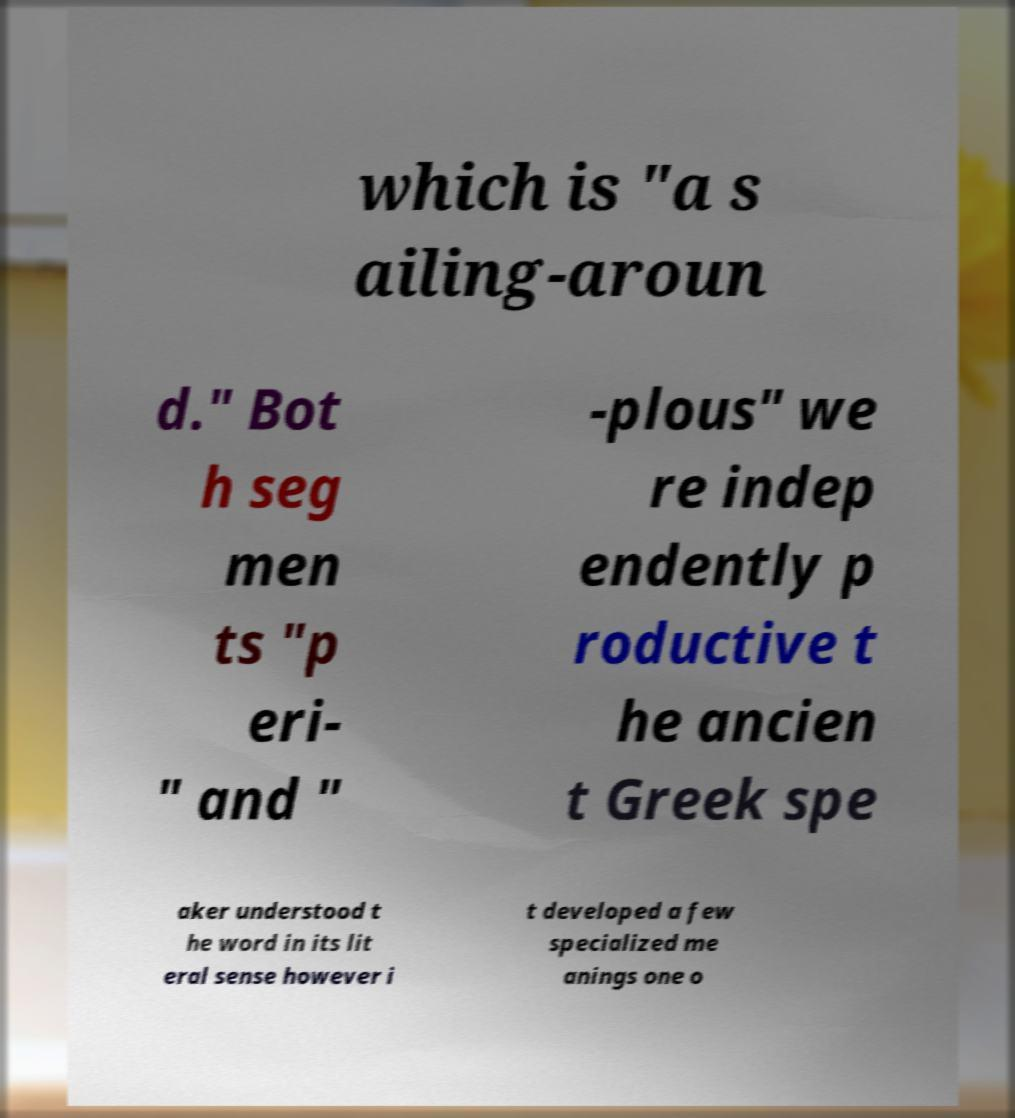Please identify and transcribe the text found in this image. which is "a s ailing-aroun d." Bot h seg men ts "p eri- " and " -plous" we re indep endently p roductive t he ancien t Greek spe aker understood t he word in its lit eral sense however i t developed a few specialized me anings one o 